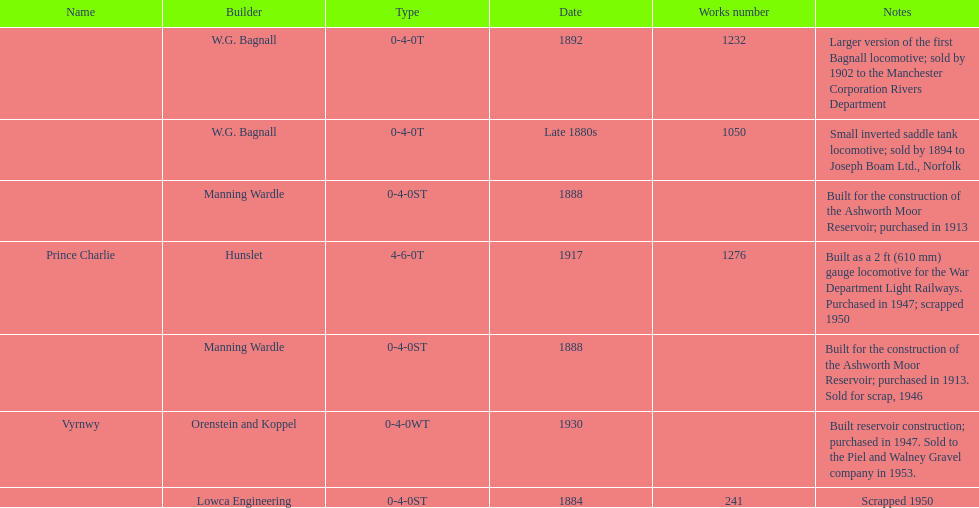How many locomotives were scrapped? 3. 